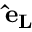Convert formula to latex. <formula><loc_0><loc_0><loc_500><loc_500>{ \hat { e } _ { L } }</formula> 